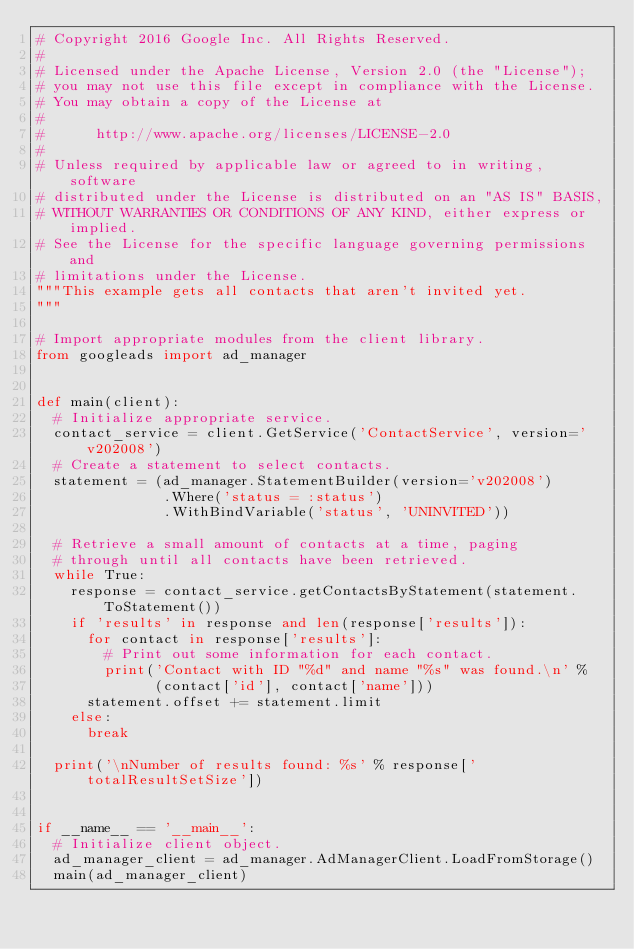Convert code to text. <code><loc_0><loc_0><loc_500><loc_500><_Python_># Copyright 2016 Google Inc. All Rights Reserved.
#
# Licensed under the Apache License, Version 2.0 (the "License");
# you may not use this file except in compliance with the License.
# You may obtain a copy of the License at
#
#      http://www.apache.org/licenses/LICENSE-2.0
#
# Unless required by applicable law or agreed to in writing, software
# distributed under the License is distributed on an "AS IS" BASIS,
# WITHOUT WARRANTIES OR CONDITIONS OF ANY KIND, either express or implied.
# See the License for the specific language governing permissions and
# limitations under the License.
"""This example gets all contacts that aren't invited yet.
"""

# Import appropriate modules from the client library.
from googleads import ad_manager


def main(client):
  # Initialize appropriate service.
  contact_service = client.GetService('ContactService', version='v202008')
  # Create a statement to select contacts.
  statement = (ad_manager.StatementBuilder(version='v202008')
               .Where('status = :status')
               .WithBindVariable('status', 'UNINVITED'))

  # Retrieve a small amount of contacts at a time, paging
  # through until all contacts have been retrieved.
  while True:
    response = contact_service.getContactsByStatement(statement.ToStatement())
    if 'results' in response and len(response['results']):
      for contact in response['results']:
        # Print out some information for each contact.
        print('Contact with ID "%d" and name "%s" was found.\n' %
              (contact['id'], contact['name']))
      statement.offset += statement.limit
    else:
      break

  print('\nNumber of results found: %s' % response['totalResultSetSize'])


if __name__ == '__main__':
  # Initialize client object.
  ad_manager_client = ad_manager.AdManagerClient.LoadFromStorage()
  main(ad_manager_client)
</code> 